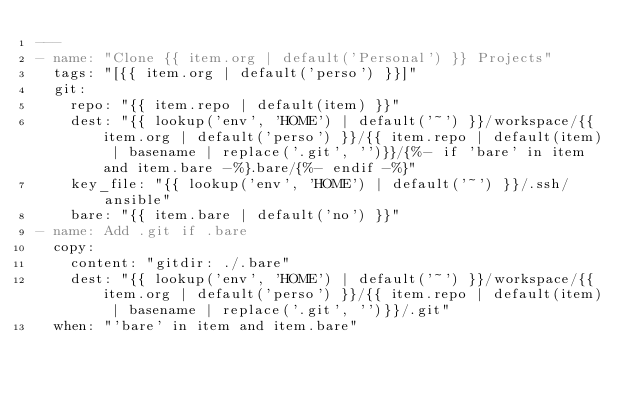Convert code to text. <code><loc_0><loc_0><loc_500><loc_500><_YAML_>---
- name: "Clone {{ item.org | default('Personal') }} Projects"
  tags: "[{{ item.org | default('perso') }}]"
  git:
    repo: "{{ item.repo | default(item) }}"
    dest: "{{ lookup('env', 'HOME') | default('~') }}/workspace/{{ item.org | default('perso') }}/{{ item.repo | default(item) | basename | replace('.git', '')}}/{%- if 'bare' in item and item.bare -%}.bare/{%- endif -%}"
    key_file: "{{ lookup('env', 'HOME') | default('~') }}/.ssh/ansible"
    bare: "{{ item.bare | default('no') }}"
- name: Add .git if .bare
  copy:
    content: "gitdir: ./.bare"
    dest: "{{ lookup('env', 'HOME') | default('~') }}/workspace/{{ item.org | default('perso') }}/{{ item.repo | default(item) | basename | replace('.git', '')}}/.git"
  when: "'bare' in item and item.bare"
</code> 